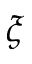<formula> <loc_0><loc_0><loc_500><loc_500>\xi</formula> 